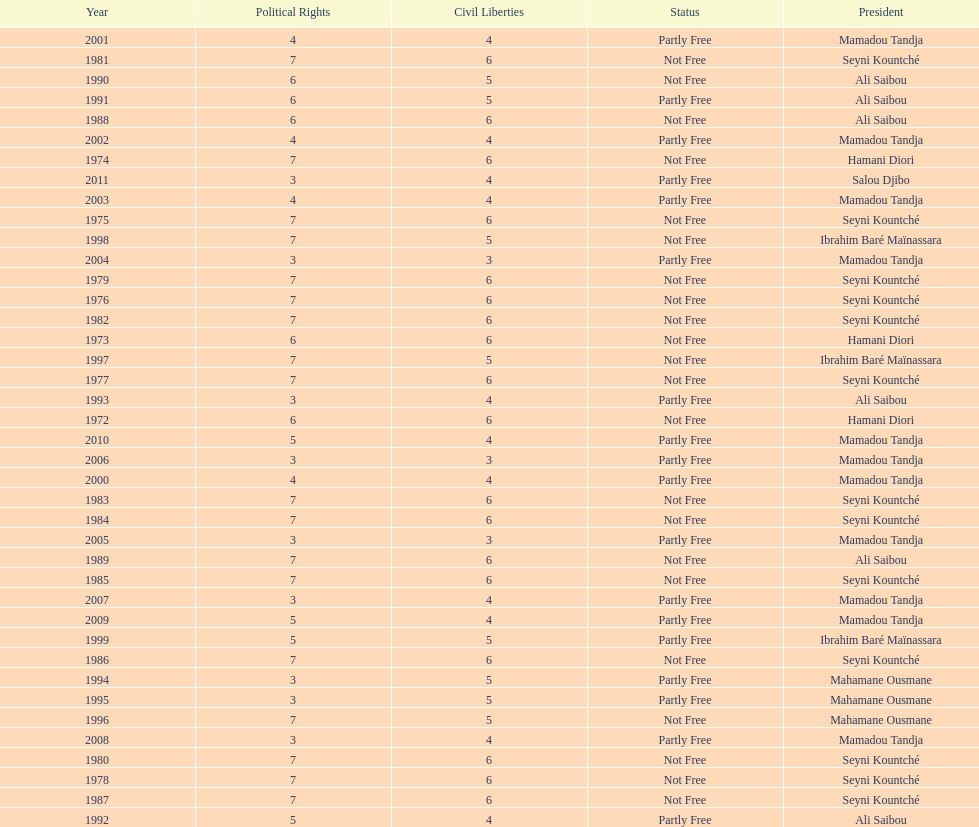How many years was ali saibou president? 6. 